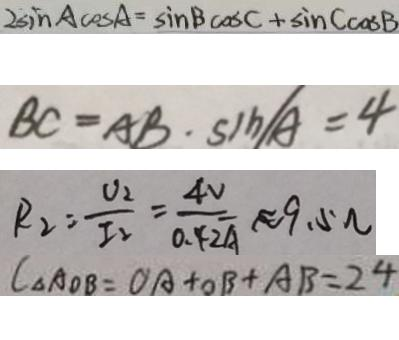<formula> <loc_0><loc_0><loc_500><loc_500>2 \sin A \cos A = \sin B \cos A + \sin C \cos B 
 B C = A B \cdot \sin / A = 4 
 R _ { 2 } = \frac { U _ { 2 } } { I _ { 2 } } = \frac { 4 V } { 0 . 4 2 A } \approx 9 . 5 \Omega 
 C _ { \Delta A O B } = O A + O B + A B = 2 4</formula> 